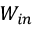<formula> <loc_0><loc_0><loc_500><loc_500>W _ { i n }</formula> 